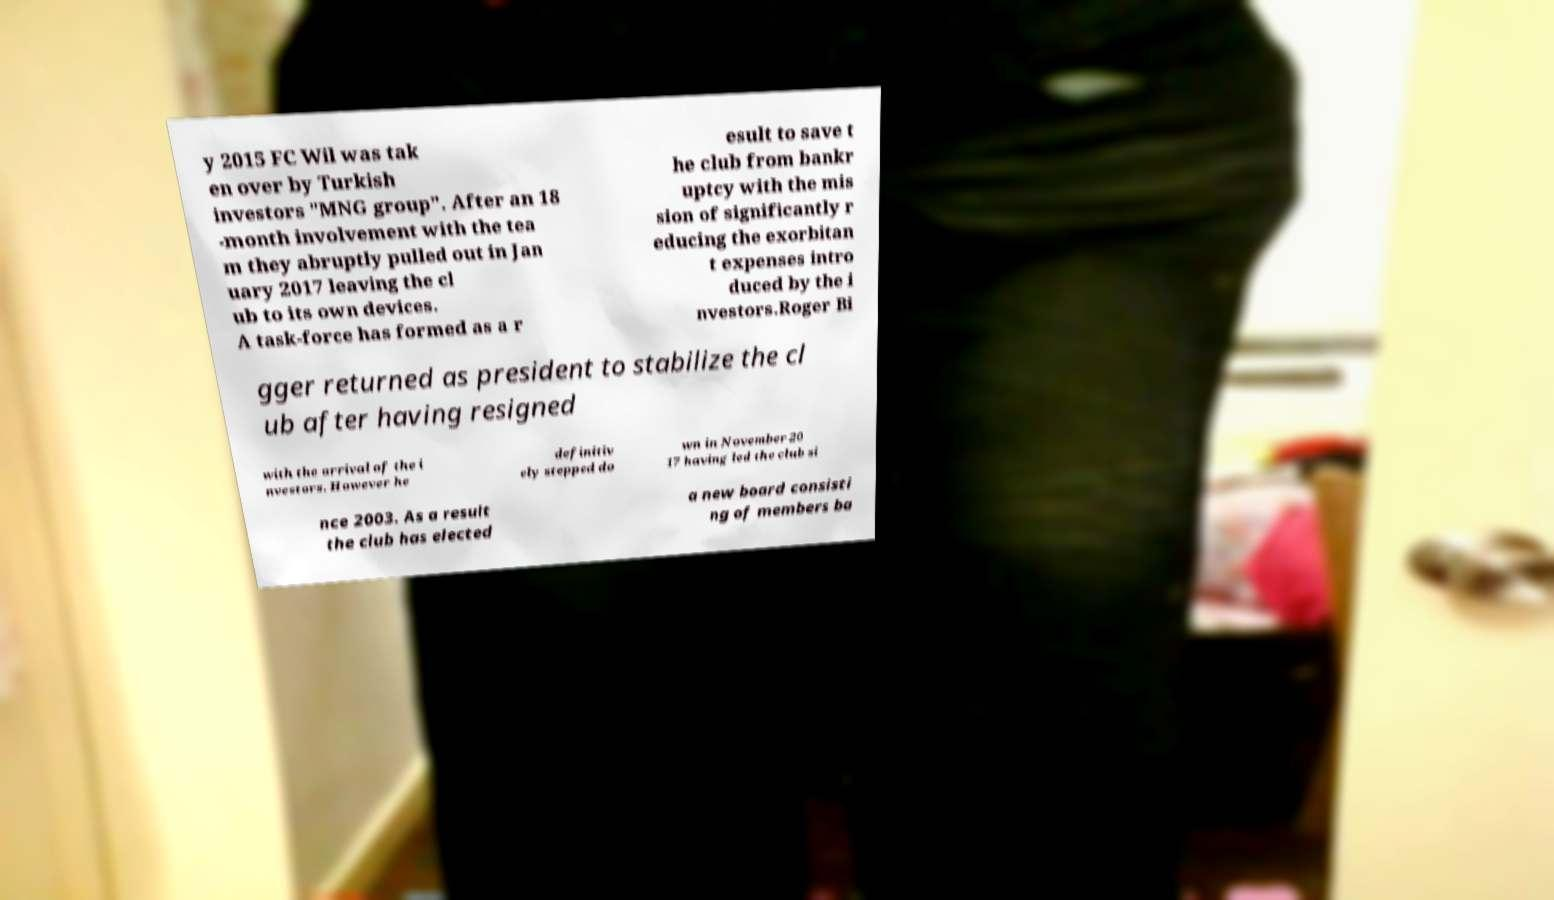Please identify and transcribe the text found in this image. y 2015 FC Wil was tak en over by Turkish investors "MNG group". After an 18 -month involvement with the tea m they abruptly pulled out in Jan uary 2017 leaving the cl ub to its own devices. A task-force has formed as a r esult to save t he club from bankr uptcy with the mis sion of significantly r educing the exorbitan t expenses intro duced by the i nvestors.Roger Bi gger returned as president to stabilize the cl ub after having resigned with the arrival of the i nvestors. However he definitiv ely stepped do wn in November 20 17 having led the club si nce 2003. As a result the club has elected a new board consisti ng of members ba 